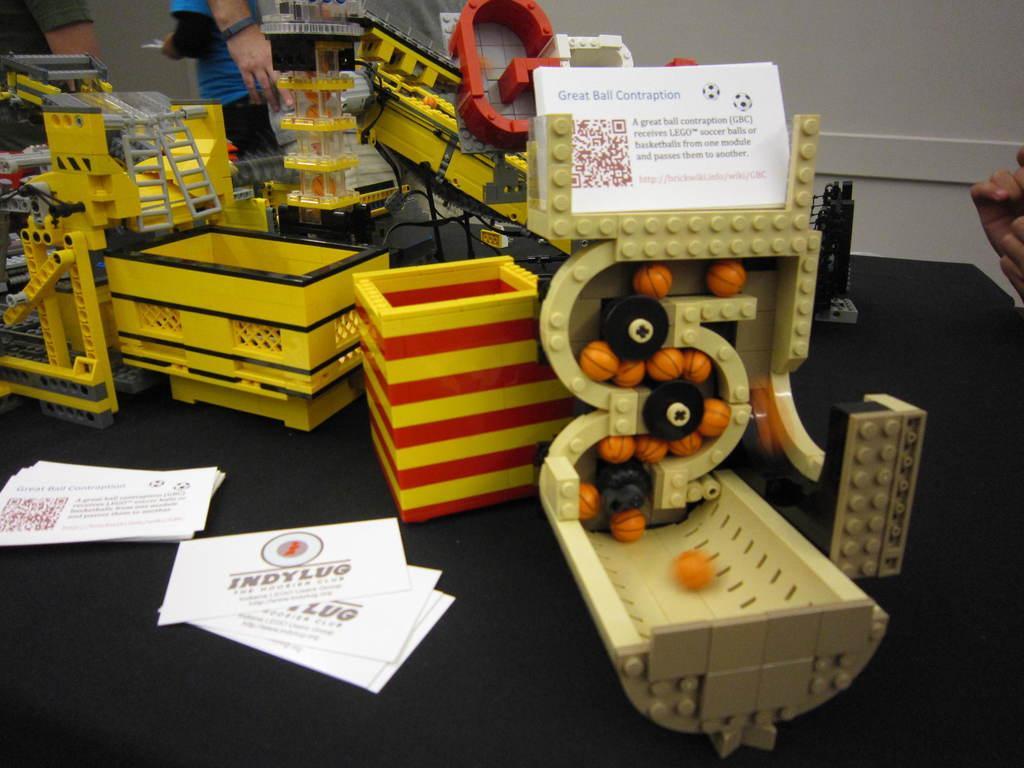Can you describe this image briefly? In this image I can see number of toys, number of white colour cards and on it I can see something is written. In the background and on the right side of this image I can see few people. 